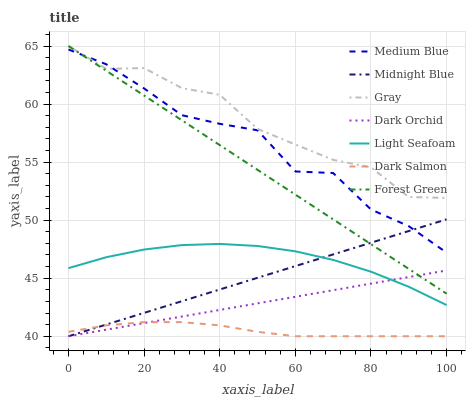Does Dark Salmon have the minimum area under the curve?
Answer yes or no. Yes. Does Gray have the maximum area under the curve?
Answer yes or no. Yes. Does Midnight Blue have the minimum area under the curve?
Answer yes or no. No. Does Midnight Blue have the maximum area under the curve?
Answer yes or no. No. Is Dark Orchid the smoothest?
Answer yes or no. Yes. Is Medium Blue the roughest?
Answer yes or no. Yes. Is Midnight Blue the smoothest?
Answer yes or no. No. Is Midnight Blue the roughest?
Answer yes or no. No. Does Midnight Blue have the lowest value?
Answer yes or no. Yes. Does Medium Blue have the lowest value?
Answer yes or no. No. Does Forest Green have the highest value?
Answer yes or no. Yes. Does Midnight Blue have the highest value?
Answer yes or no. No. Is Dark Salmon less than Medium Blue?
Answer yes or no. Yes. Is Medium Blue greater than Light Seafoam?
Answer yes or no. Yes. Does Dark Salmon intersect Dark Orchid?
Answer yes or no. Yes. Is Dark Salmon less than Dark Orchid?
Answer yes or no. No. Is Dark Salmon greater than Dark Orchid?
Answer yes or no. No. Does Dark Salmon intersect Medium Blue?
Answer yes or no. No. 